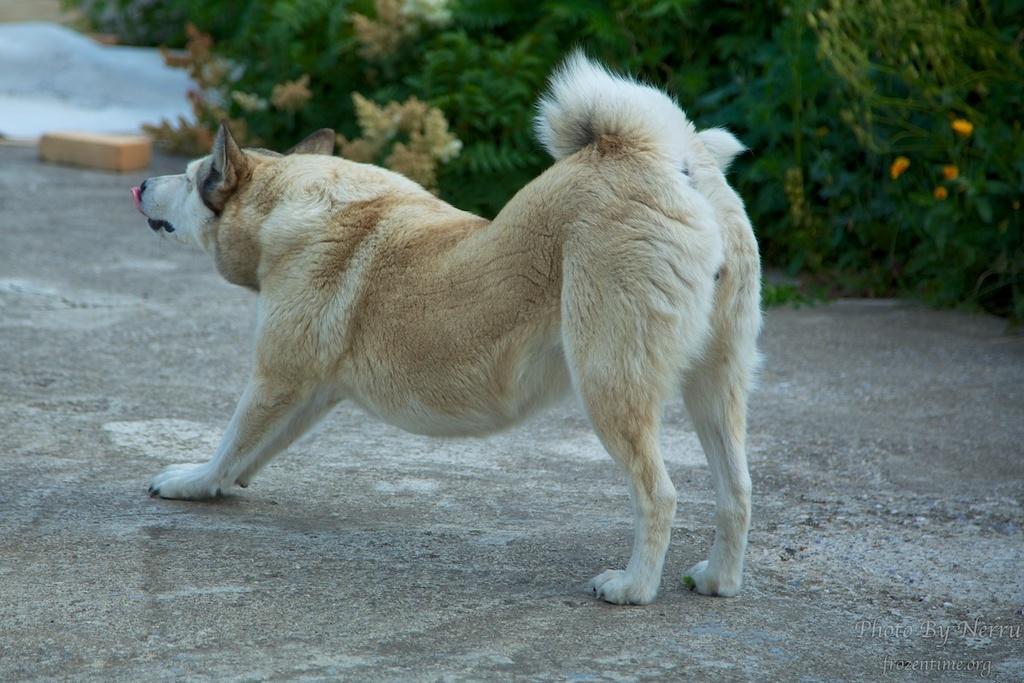How would you summarize this image in a sentence or two? In this image I see a dog over here which is of white and cream in color and I see the path and I see the watermark over here. In the background I see the planets and I see a thing over here. 